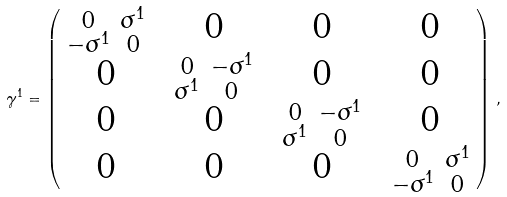Convert formula to latex. <formula><loc_0><loc_0><loc_500><loc_500>\, \gamma ^ { 1 } = \begin{pmatrix} \begin{smallmatrix} 0 & \sigma ^ { 1 } \\ - \sigma ^ { 1 } & 0 \end{smallmatrix} & 0 & 0 & 0 \\ 0 & \begin{smallmatrix} 0 & - \sigma ^ { 1 } \\ \sigma ^ { 1 } & 0 \end{smallmatrix} & 0 & 0 \\ 0 & 0 & \begin{smallmatrix} 0 & - \sigma ^ { 1 } \\ \sigma ^ { 1 } & 0 \end{smallmatrix} & 0 \\ 0 & 0 & 0 & \begin{smallmatrix} 0 & \sigma ^ { 1 } \\ - \sigma ^ { 1 } & 0 \end{smallmatrix} \end{pmatrix} \, , \\</formula> 